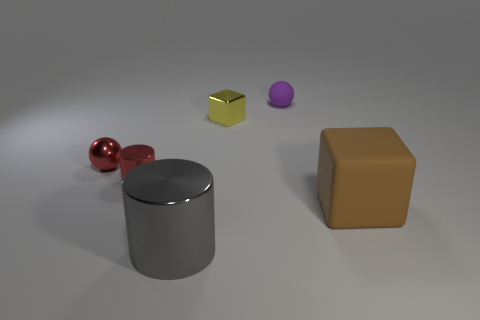What is the shape of the tiny object that is the same color as the small metallic sphere?
Provide a short and direct response. Cylinder. How many blue matte things have the same size as the purple ball?
Provide a succinct answer. 0. Is the shape of the big brown rubber thing the same as the yellow thing?
Provide a short and direct response. Yes. The small object right of the metallic object on the right side of the gray metal cylinder is what color?
Your response must be concise. Purple. There is a metallic thing that is both in front of the small metal sphere and behind the brown matte thing; what size is it?
Provide a short and direct response. Small. Are there any other things that are the same color as the tiny block?
Ensure brevity in your answer.  No. The other object that is made of the same material as the brown thing is what shape?
Your response must be concise. Sphere. There is a yellow object; is it the same shape as the big gray metal thing left of the yellow metallic cube?
Your response must be concise. No. There is a large object left of the tiny ball that is right of the red ball; what is its material?
Ensure brevity in your answer.  Metal. Are there an equal number of tiny yellow shiny cubes in front of the red shiny sphere and small red metallic objects?
Keep it short and to the point. No. 